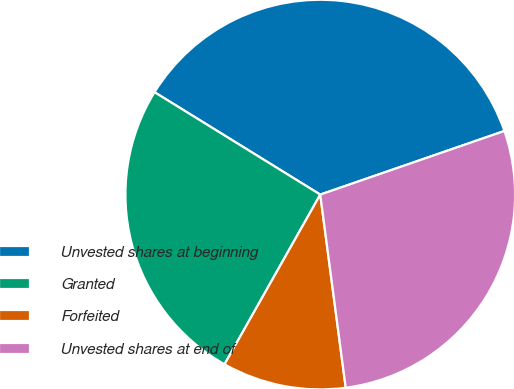<chart> <loc_0><loc_0><loc_500><loc_500><pie_chart><fcel>Unvested shares at beginning<fcel>Granted<fcel>Forfeited<fcel>Unvested shares at end of<nl><fcel>35.9%<fcel>25.64%<fcel>10.26%<fcel>28.21%<nl></chart> 